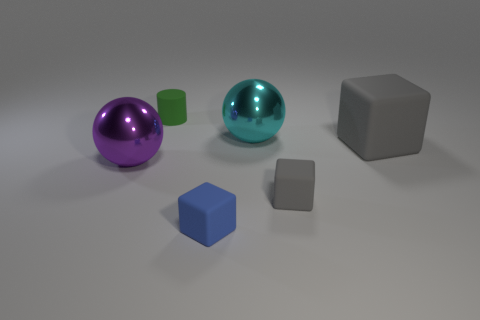There is a big cube; is it the same color as the tiny rubber block to the right of the big cyan metallic thing?
Keep it short and to the point. Yes. Is the color of the tiny rubber cube that is behind the blue block the same as the big rubber block?
Provide a short and direct response. Yes. There is a small object that is behind the big metal sphere right of the metallic thing in front of the cyan thing; what is its shape?
Your answer should be compact. Cylinder. What number of blocks are tiny blue objects or big purple rubber objects?
Keep it short and to the point. 1. Are there any gray rubber things behind the metallic ball right of the small cylinder?
Your response must be concise. No. Is there anything else that has the same material as the big purple ball?
Provide a short and direct response. Yes. Is the shape of the green thing the same as the blue thing that is on the left side of the small gray object?
Make the answer very short. No. How many blue things are tiny rubber cylinders or large shiny objects?
Offer a terse response. 0. What number of rubber objects are in front of the big cyan ball and behind the tiny blue object?
Provide a succinct answer. 2. What material is the cylinder that is behind the gray rubber block behind the small gray block that is on the right side of the small green rubber thing made of?
Your response must be concise. Rubber. 